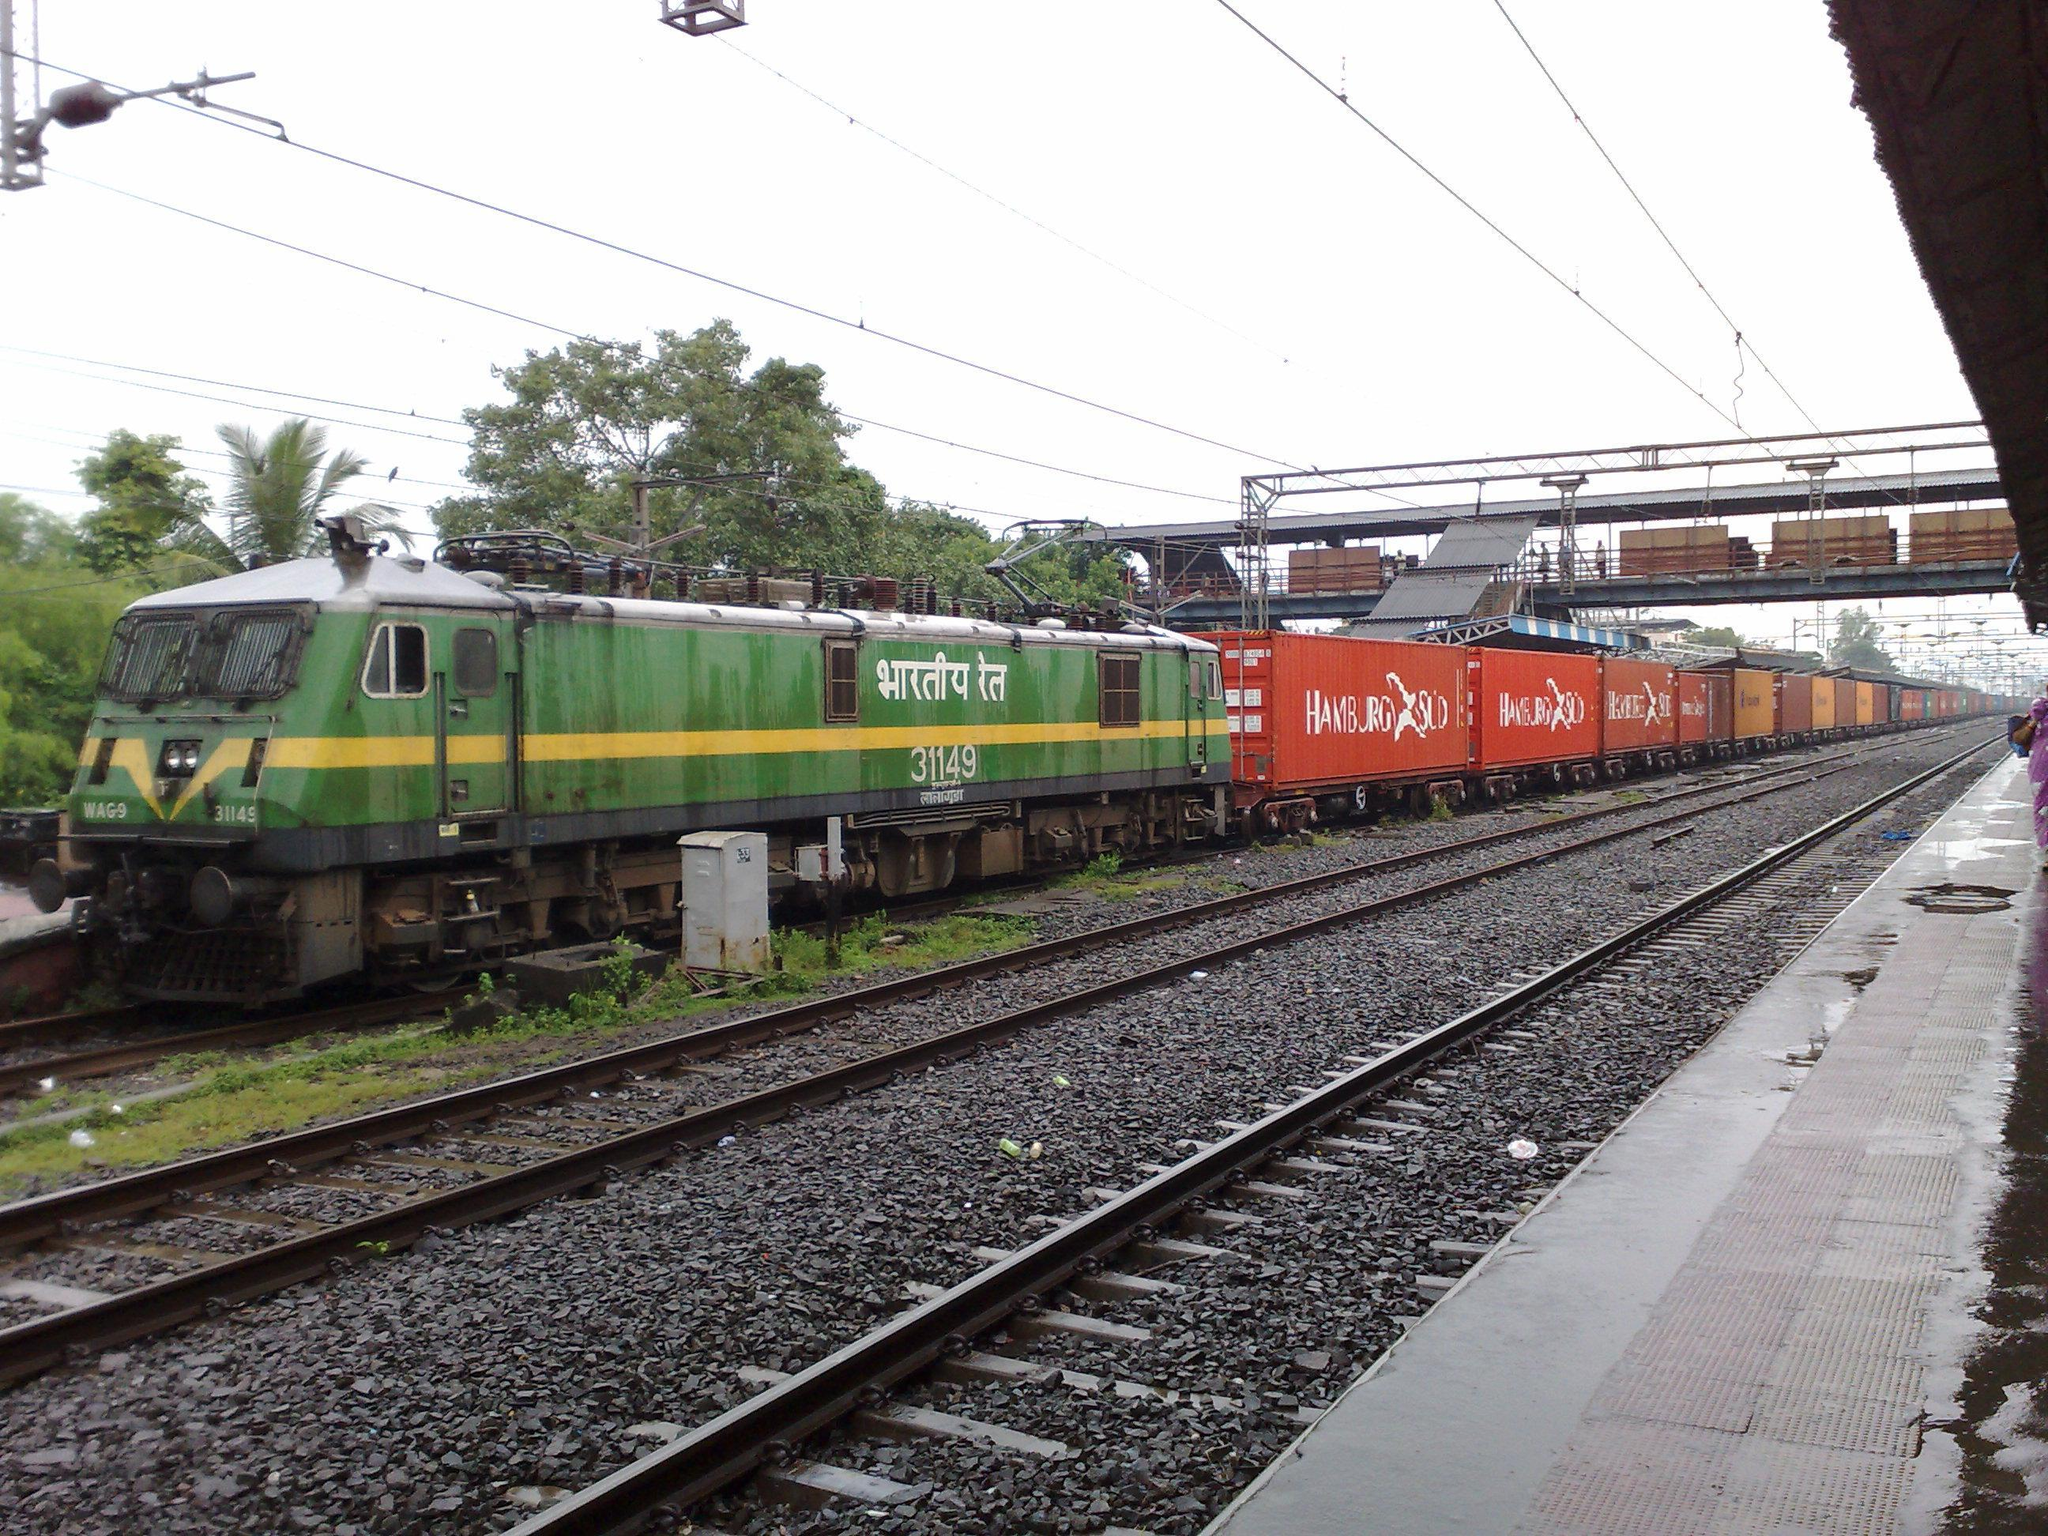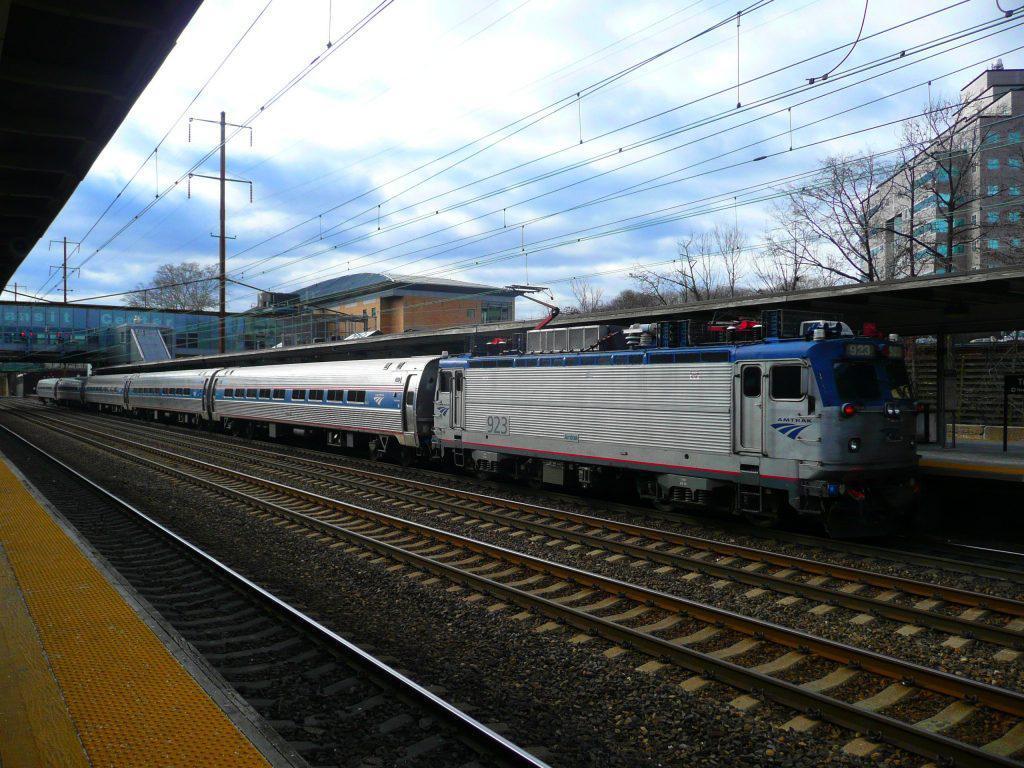The first image is the image on the left, the second image is the image on the right. Analyze the images presented: Is the assertion "Multiple people stand to one side of a train in one image, but no one is by the train in the other image, which angles rightward." valid? Answer yes or no. No. The first image is the image on the left, the second image is the image on the right. Evaluate the accuracy of this statement regarding the images: "Several people are standing on the platform near the train in the image on the left.". Is it true? Answer yes or no. No. 